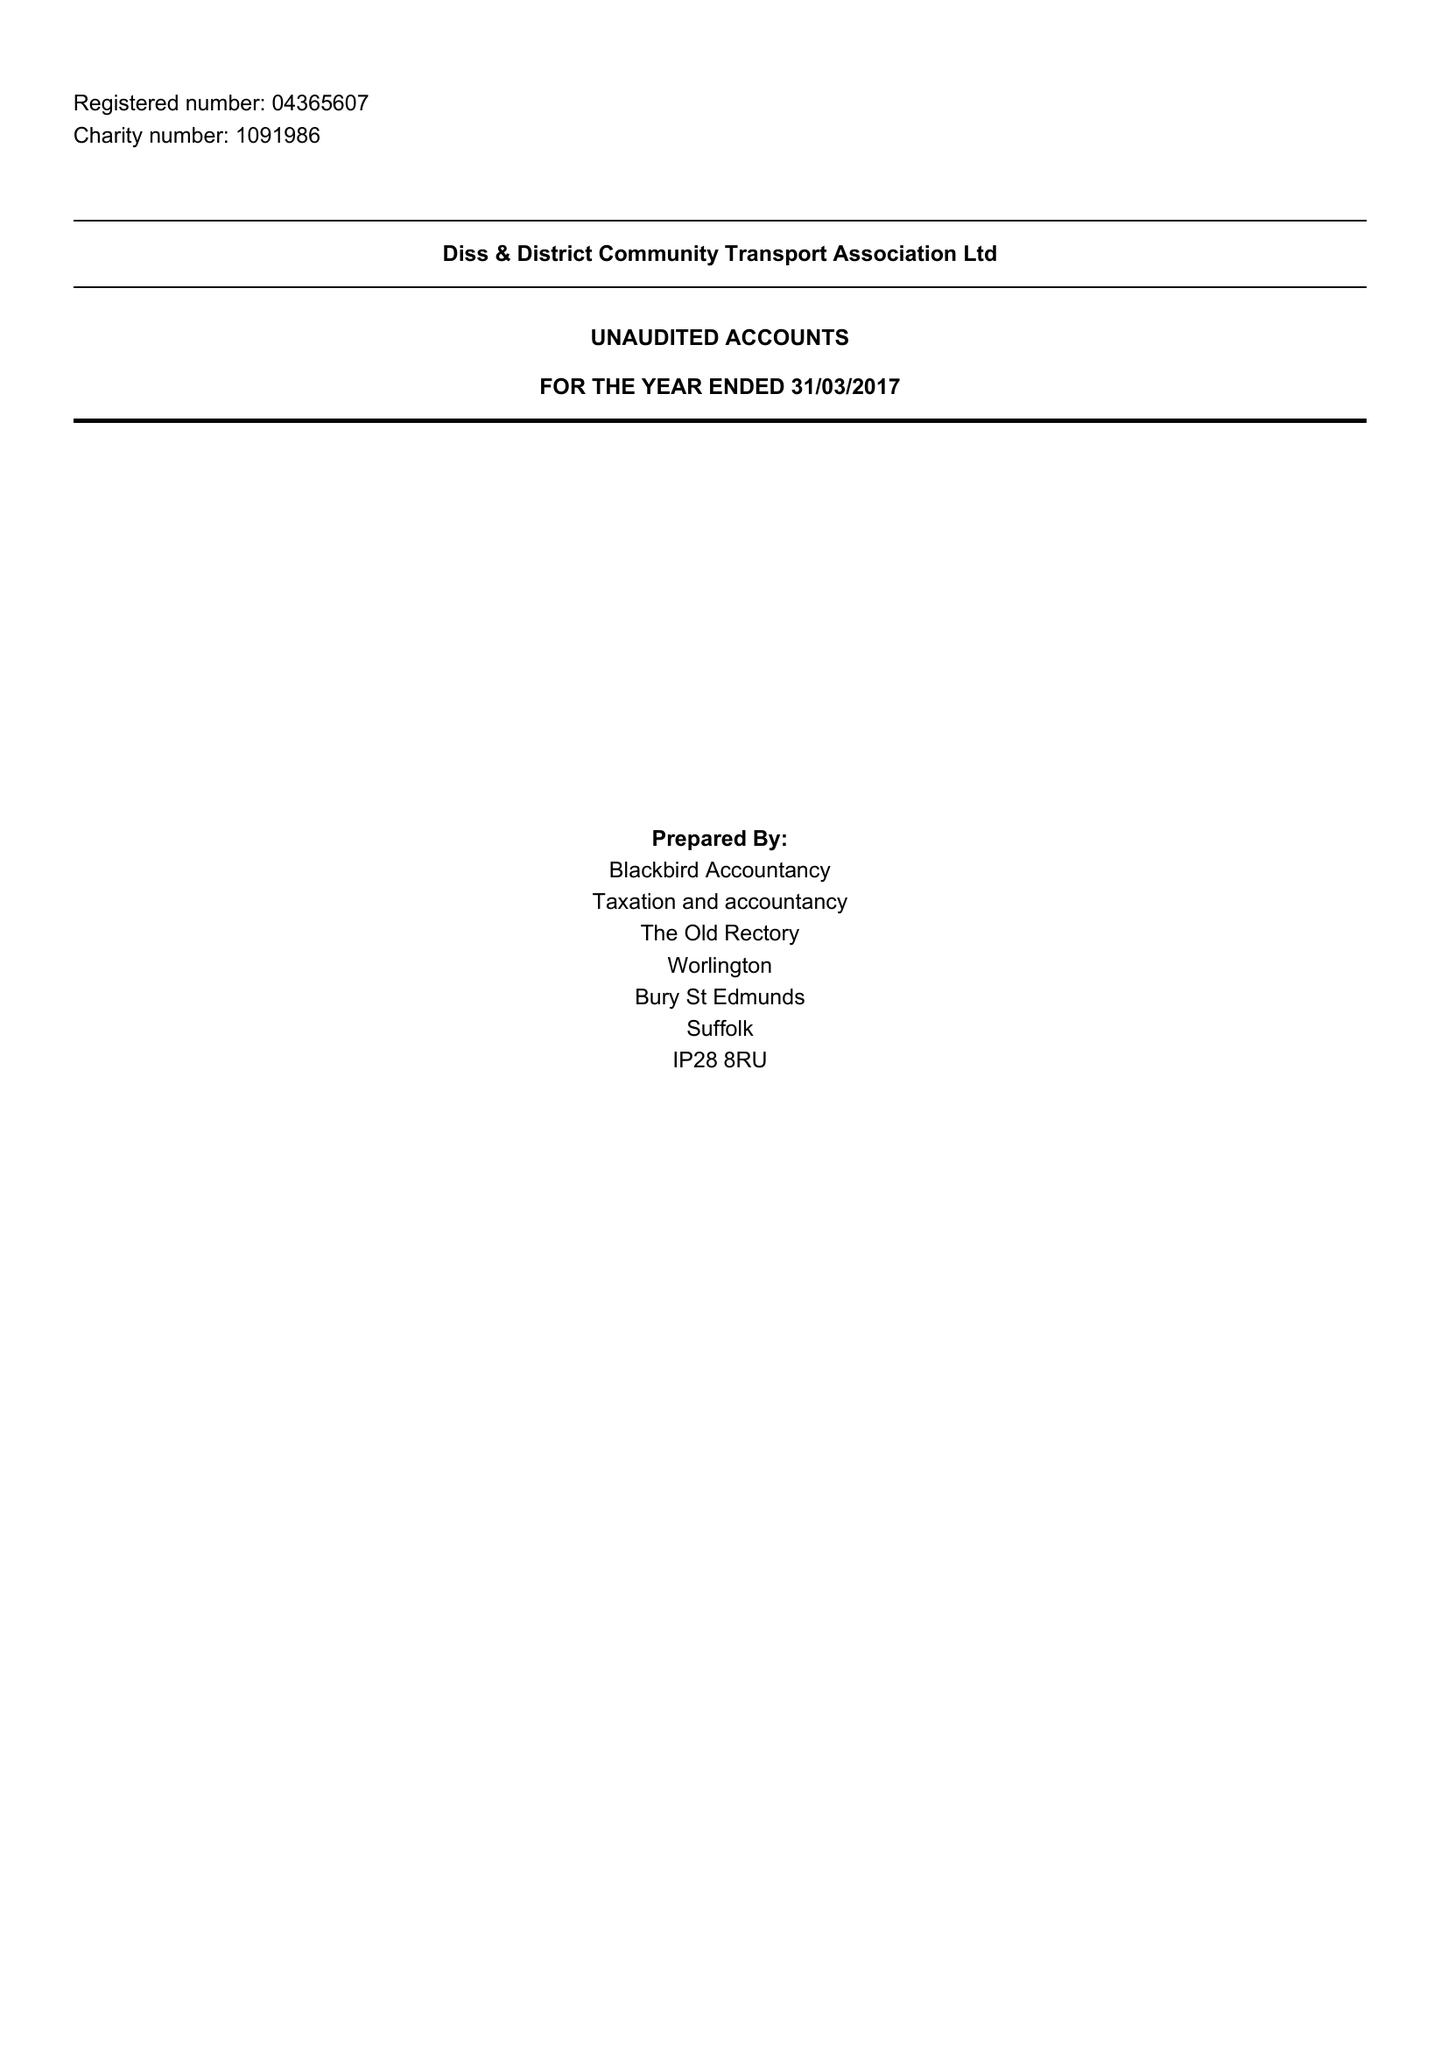What is the value for the income_annually_in_british_pounds?
Answer the question using a single word or phrase. 176840.00 